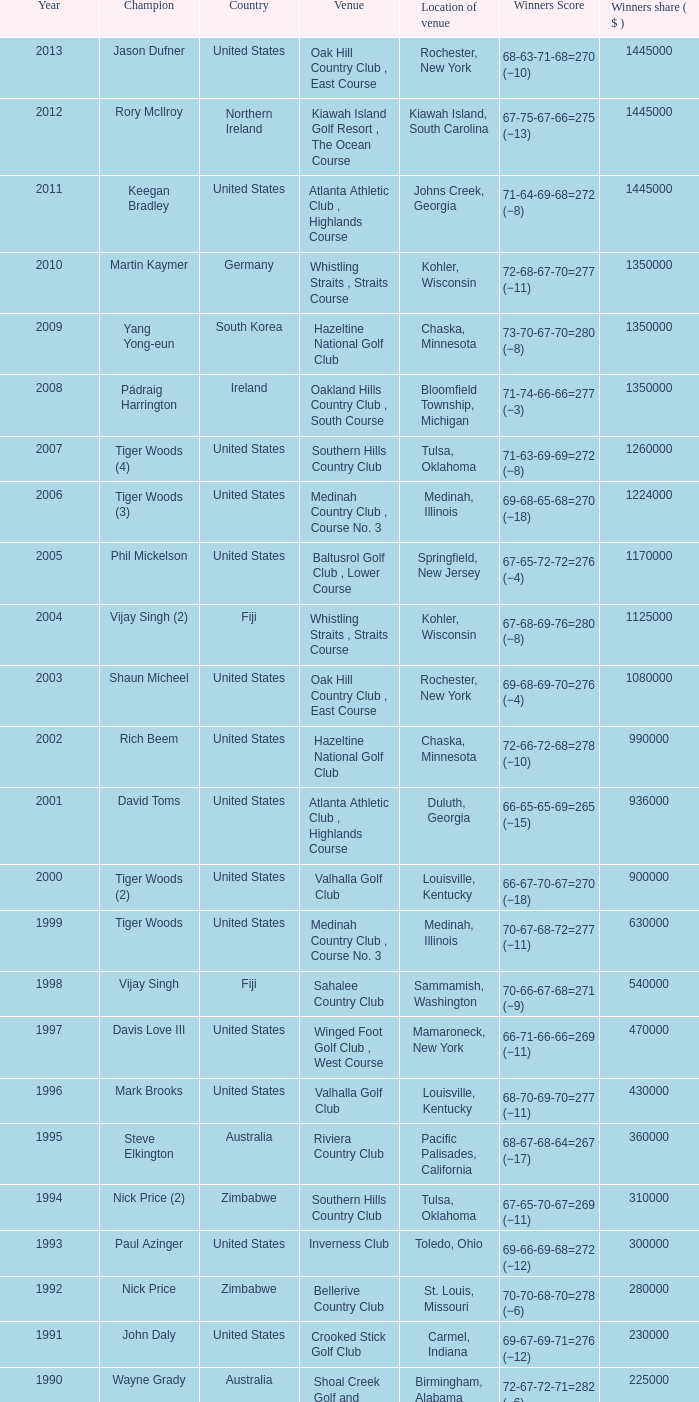In which location is the bellerive country club venue positioned? St. Louis, Missouri. 